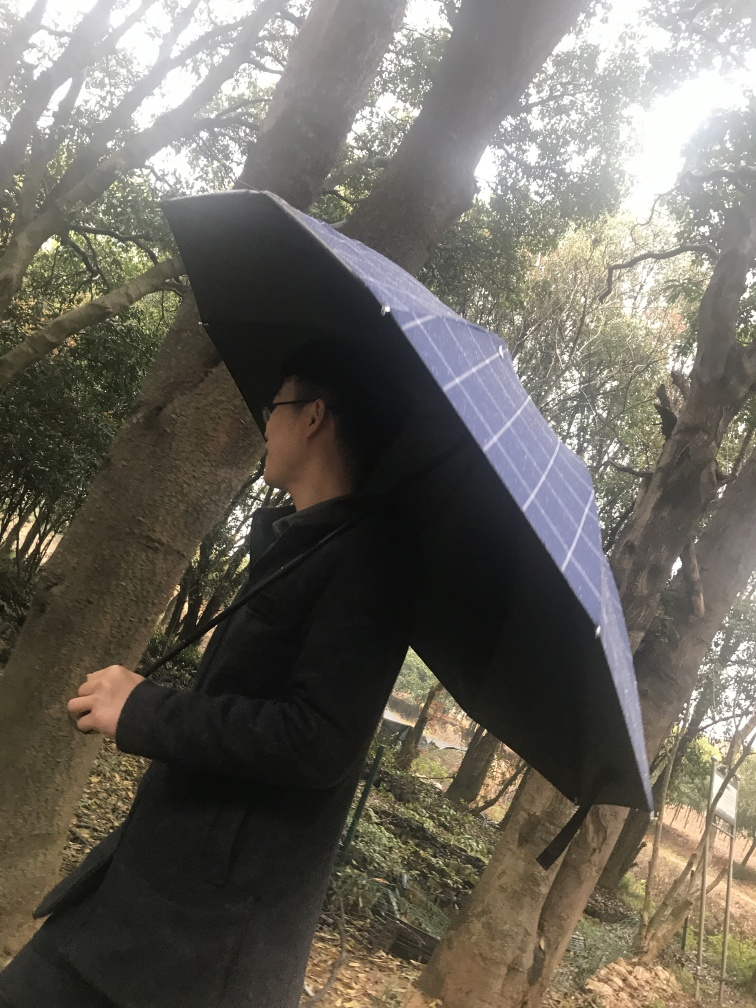Are there any quality issues with this image? The image is slightly tilted and lacks sharpness, which suggests that it may have been taken hastily or with an unsteady hand. Additionally, the overcast lighting conditions lead to a flat and somewhat dull appearance. Some details are lost in shadow, particularly under the umbrella and in the darker areas of the coat. The positioning of the subject with their back to the camera makes it hard to connect with the person in the image. 